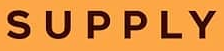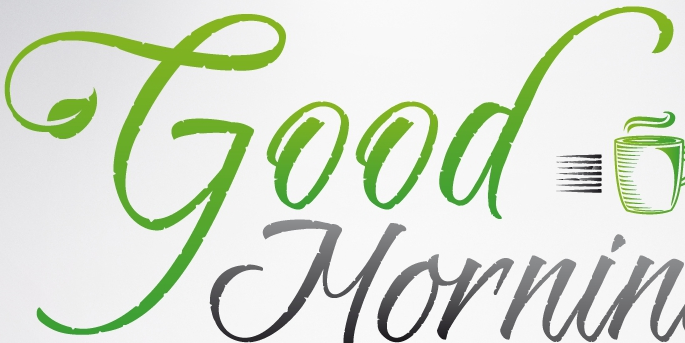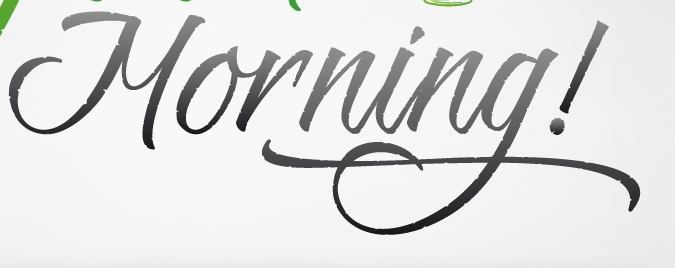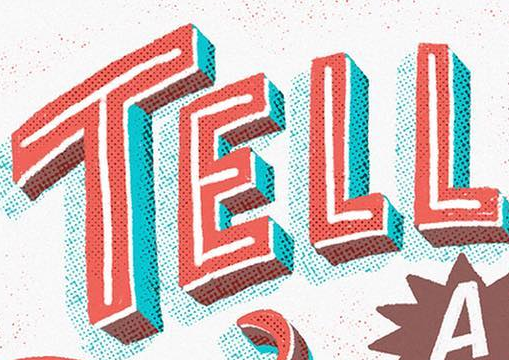Read the text from these images in sequence, separated by a semicolon. SUPPLY; Good; Morning!; TELL 